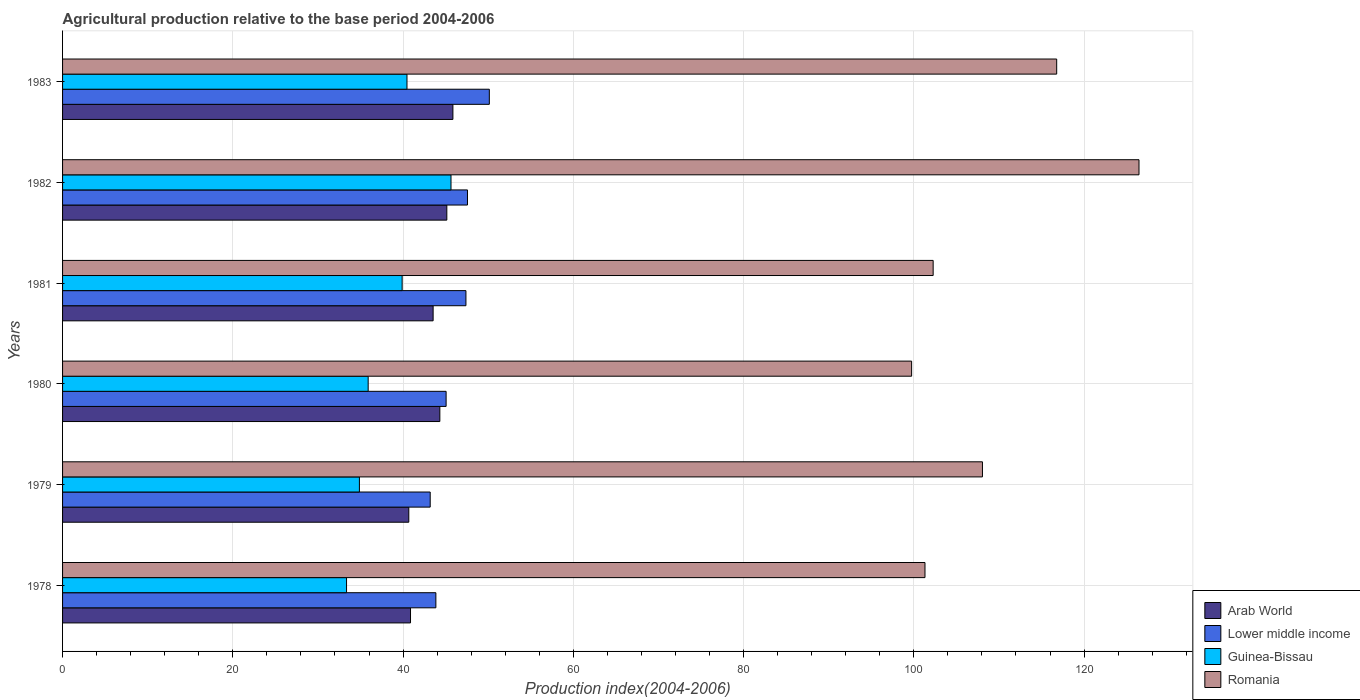Are the number of bars on each tick of the Y-axis equal?
Your response must be concise. Yes. How many bars are there on the 1st tick from the top?
Offer a very short reply. 4. What is the agricultural production index in Romania in 1983?
Give a very brief answer. 116.78. Across all years, what is the maximum agricultural production index in Lower middle income?
Ensure brevity in your answer.  50.13. Across all years, what is the minimum agricultural production index in Guinea-Bissau?
Make the answer very short. 33.36. In which year was the agricultural production index in Romania maximum?
Ensure brevity in your answer.  1982. What is the total agricultural production index in Lower middle income in the graph?
Give a very brief answer. 277.18. What is the difference between the agricultural production index in Arab World in 1980 and that in 1981?
Offer a very short reply. 0.79. What is the difference between the agricultural production index in Arab World in 1981 and the agricultural production index in Guinea-Bissau in 1983?
Provide a short and direct response. 3.07. What is the average agricultural production index in Guinea-Bissau per year?
Your answer should be very brief. 38.35. In the year 1980, what is the difference between the agricultural production index in Arab World and agricultural production index in Guinea-Bissau?
Offer a terse response. 8.42. In how many years, is the agricultural production index in Romania greater than 36 ?
Offer a very short reply. 6. What is the ratio of the agricultural production index in Guinea-Bissau in 1978 to that in 1982?
Your answer should be compact. 0.73. Is the difference between the agricultural production index in Arab World in 1979 and 1980 greater than the difference between the agricultural production index in Guinea-Bissau in 1979 and 1980?
Your response must be concise. No. What is the difference between the highest and the second highest agricultural production index in Arab World?
Make the answer very short. 0.71. What is the difference between the highest and the lowest agricultural production index in Lower middle income?
Your answer should be compact. 6.95. Is the sum of the agricultural production index in Lower middle income in 1982 and 1983 greater than the maximum agricultural production index in Guinea-Bissau across all years?
Provide a succinct answer. Yes. Is it the case that in every year, the sum of the agricultural production index in Romania and agricultural production index in Lower middle income is greater than the sum of agricultural production index in Arab World and agricultural production index in Guinea-Bissau?
Your answer should be compact. Yes. What does the 1st bar from the top in 1978 represents?
Keep it short and to the point. Romania. What does the 3rd bar from the bottom in 1978 represents?
Provide a short and direct response. Guinea-Bissau. How many bars are there?
Your answer should be compact. 24. What is the difference between two consecutive major ticks on the X-axis?
Offer a terse response. 20. Are the values on the major ticks of X-axis written in scientific E-notation?
Your answer should be compact. No. Where does the legend appear in the graph?
Your response must be concise. Bottom right. How are the legend labels stacked?
Your response must be concise. Vertical. What is the title of the graph?
Keep it short and to the point. Agricultural production relative to the base period 2004-2006. Does "Cyprus" appear as one of the legend labels in the graph?
Provide a short and direct response. No. What is the label or title of the X-axis?
Your answer should be compact. Production index(2004-2006). What is the label or title of the Y-axis?
Your response must be concise. Years. What is the Production index(2004-2006) of Arab World in 1978?
Provide a succinct answer. 40.87. What is the Production index(2004-2006) of Lower middle income in 1978?
Ensure brevity in your answer.  43.85. What is the Production index(2004-2006) of Guinea-Bissau in 1978?
Your response must be concise. 33.36. What is the Production index(2004-2006) of Romania in 1978?
Your response must be concise. 101.31. What is the Production index(2004-2006) in Arab World in 1979?
Give a very brief answer. 40.67. What is the Production index(2004-2006) in Lower middle income in 1979?
Your answer should be compact. 43.19. What is the Production index(2004-2006) of Guinea-Bissau in 1979?
Offer a very short reply. 34.87. What is the Production index(2004-2006) of Romania in 1979?
Your answer should be compact. 108.06. What is the Production index(2004-2006) of Arab World in 1980?
Offer a very short reply. 44.32. What is the Production index(2004-2006) of Lower middle income in 1980?
Offer a very short reply. 45.06. What is the Production index(2004-2006) of Guinea-Bissau in 1980?
Your answer should be very brief. 35.9. What is the Production index(2004-2006) of Romania in 1980?
Offer a terse response. 99.74. What is the Production index(2004-2006) in Arab World in 1981?
Ensure brevity in your answer.  43.53. What is the Production index(2004-2006) in Lower middle income in 1981?
Make the answer very short. 47.38. What is the Production index(2004-2006) in Guinea-Bissau in 1981?
Your answer should be compact. 39.89. What is the Production index(2004-2006) in Romania in 1981?
Your answer should be very brief. 102.27. What is the Production index(2004-2006) in Arab World in 1982?
Provide a succinct answer. 45.14. What is the Production index(2004-2006) of Lower middle income in 1982?
Provide a short and direct response. 47.57. What is the Production index(2004-2006) in Guinea-Bissau in 1982?
Offer a very short reply. 45.63. What is the Production index(2004-2006) in Romania in 1982?
Provide a succinct answer. 126.45. What is the Production index(2004-2006) in Arab World in 1983?
Your answer should be very brief. 45.85. What is the Production index(2004-2006) of Lower middle income in 1983?
Your response must be concise. 50.13. What is the Production index(2004-2006) in Guinea-Bissau in 1983?
Your answer should be compact. 40.46. What is the Production index(2004-2006) in Romania in 1983?
Give a very brief answer. 116.78. Across all years, what is the maximum Production index(2004-2006) in Arab World?
Make the answer very short. 45.85. Across all years, what is the maximum Production index(2004-2006) of Lower middle income?
Offer a terse response. 50.13. Across all years, what is the maximum Production index(2004-2006) in Guinea-Bissau?
Provide a succinct answer. 45.63. Across all years, what is the maximum Production index(2004-2006) in Romania?
Give a very brief answer. 126.45. Across all years, what is the minimum Production index(2004-2006) in Arab World?
Make the answer very short. 40.67. Across all years, what is the minimum Production index(2004-2006) in Lower middle income?
Provide a succinct answer. 43.19. Across all years, what is the minimum Production index(2004-2006) of Guinea-Bissau?
Give a very brief answer. 33.36. Across all years, what is the minimum Production index(2004-2006) in Romania?
Ensure brevity in your answer.  99.74. What is the total Production index(2004-2006) of Arab World in the graph?
Your response must be concise. 260.39. What is the total Production index(2004-2006) in Lower middle income in the graph?
Your response must be concise. 277.18. What is the total Production index(2004-2006) of Guinea-Bissau in the graph?
Your answer should be compact. 230.11. What is the total Production index(2004-2006) of Romania in the graph?
Offer a very short reply. 654.61. What is the difference between the Production index(2004-2006) in Arab World in 1978 and that in 1979?
Your response must be concise. 0.2. What is the difference between the Production index(2004-2006) of Lower middle income in 1978 and that in 1979?
Ensure brevity in your answer.  0.67. What is the difference between the Production index(2004-2006) of Guinea-Bissau in 1978 and that in 1979?
Your response must be concise. -1.51. What is the difference between the Production index(2004-2006) of Romania in 1978 and that in 1979?
Give a very brief answer. -6.75. What is the difference between the Production index(2004-2006) in Arab World in 1978 and that in 1980?
Give a very brief answer. -3.45. What is the difference between the Production index(2004-2006) of Lower middle income in 1978 and that in 1980?
Your response must be concise. -1.2. What is the difference between the Production index(2004-2006) in Guinea-Bissau in 1978 and that in 1980?
Make the answer very short. -2.54. What is the difference between the Production index(2004-2006) of Romania in 1978 and that in 1980?
Ensure brevity in your answer.  1.57. What is the difference between the Production index(2004-2006) of Arab World in 1978 and that in 1981?
Offer a terse response. -2.66. What is the difference between the Production index(2004-2006) of Lower middle income in 1978 and that in 1981?
Your answer should be very brief. -3.53. What is the difference between the Production index(2004-2006) of Guinea-Bissau in 1978 and that in 1981?
Keep it short and to the point. -6.53. What is the difference between the Production index(2004-2006) in Romania in 1978 and that in 1981?
Ensure brevity in your answer.  -0.96. What is the difference between the Production index(2004-2006) in Arab World in 1978 and that in 1982?
Your response must be concise. -4.27. What is the difference between the Production index(2004-2006) in Lower middle income in 1978 and that in 1982?
Your response must be concise. -3.71. What is the difference between the Production index(2004-2006) of Guinea-Bissau in 1978 and that in 1982?
Your response must be concise. -12.27. What is the difference between the Production index(2004-2006) in Romania in 1978 and that in 1982?
Provide a succinct answer. -25.14. What is the difference between the Production index(2004-2006) in Arab World in 1978 and that in 1983?
Provide a succinct answer. -4.98. What is the difference between the Production index(2004-2006) of Lower middle income in 1978 and that in 1983?
Your response must be concise. -6.28. What is the difference between the Production index(2004-2006) of Guinea-Bissau in 1978 and that in 1983?
Provide a short and direct response. -7.1. What is the difference between the Production index(2004-2006) in Romania in 1978 and that in 1983?
Provide a short and direct response. -15.47. What is the difference between the Production index(2004-2006) of Arab World in 1979 and that in 1980?
Offer a very short reply. -3.65. What is the difference between the Production index(2004-2006) in Lower middle income in 1979 and that in 1980?
Ensure brevity in your answer.  -1.87. What is the difference between the Production index(2004-2006) in Guinea-Bissau in 1979 and that in 1980?
Offer a very short reply. -1.03. What is the difference between the Production index(2004-2006) in Romania in 1979 and that in 1980?
Your response must be concise. 8.32. What is the difference between the Production index(2004-2006) in Arab World in 1979 and that in 1981?
Provide a short and direct response. -2.86. What is the difference between the Production index(2004-2006) in Lower middle income in 1979 and that in 1981?
Offer a terse response. -4.2. What is the difference between the Production index(2004-2006) in Guinea-Bissau in 1979 and that in 1981?
Keep it short and to the point. -5.02. What is the difference between the Production index(2004-2006) of Romania in 1979 and that in 1981?
Ensure brevity in your answer.  5.79. What is the difference between the Production index(2004-2006) of Arab World in 1979 and that in 1982?
Provide a succinct answer. -4.47. What is the difference between the Production index(2004-2006) of Lower middle income in 1979 and that in 1982?
Ensure brevity in your answer.  -4.38. What is the difference between the Production index(2004-2006) in Guinea-Bissau in 1979 and that in 1982?
Offer a very short reply. -10.76. What is the difference between the Production index(2004-2006) in Romania in 1979 and that in 1982?
Offer a terse response. -18.39. What is the difference between the Production index(2004-2006) of Arab World in 1979 and that in 1983?
Give a very brief answer. -5.18. What is the difference between the Production index(2004-2006) of Lower middle income in 1979 and that in 1983?
Your response must be concise. -6.95. What is the difference between the Production index(2004-2006) of Guinea-Bissau in 1979 and that in 1983?
Ensure brevity in your answer.  -5.59. What is the difference between the Production index(2004-2006) in Romania in 1979 and that in 1983?
Give a very brief answer. -8.72. What is the difference between the Production index(2004-2006) in Arab World in 1980 and that in 1981?
Provide a short and direct response. 0.79. What is the difference between the Production index(2004-2006) in Lower middle income in 1980 and that in 1981?
Offer a terse response. -2.33. What is the difference between the Production index(2004-2006) of Guinea-Bissau in 1980 and that in 1981?
Your answer should be compact. -3.99. What is the difference between the Production index(2004-2006) in Romania in 1980 and that in 1981?
Offer a very short reply. -2.53. What is the difference between the Production index(2004-2006) in Arab World in 1980 and that in 1982?
Provide a succinct answer. -0.82. What is the difference between the Production index(2004-2006) of Lower middle income in 1980 and that in 1982?
Offer a very short reply. -2.51. What is the difference between the Production index(2004-2006) in Guinea-Bissau in 1980 and that in 1982?
Make the answer very short. -9.73. What is the difference between the Production index(2004-2006) of Romania in 1980 and that in 1982?
Give a very brief answer. -26.71. What is the difference between the Production index(2004-2006) in Arab World in 1980 and that in 1983?
Give a very brief answer. -1.54. What is the difference between the Production index(2004-2006) in Lower middle income in 1980 and that in 1983?
Your answer should be very brief. -5.08. What is the difference between the Production index(2004-2006) of Guinea-Bissau in 1980 and that in 1983?
Make the answer very short. -4.56. What is the difference between the Production index(2004-2006) in Romania in 1980 and that in 1983?
Offer a terse response. -17.04. What is the difference between the Production index(2004-2006) in Arab World in 1981 and that in 1982?
Offer a terse response. -1.61. What is the difference between the Production index(2004-2006) of Lower middle income in 1981 and that in 1982?
Give a very brief answer. -0.18. What is the difference between the Production index(2004-2006) in Guinea-Bissau in 1981 and that in 1982?
Offer a very short reply. -5.74. What is the difference between the Production index(2004-2006) in Romania in 1981 and that in 1982?
Offer a very short reply. -24.18. What is the difference between the Production index(2004-2006) of Arab World in 1981 and that in 1983?
Provide a short and direct response. -2.33. What is the difference between the Production index(2004-2006) of Lower middle income in 1981 and that in 1983?
Give a very brief answer. -2.75. What is the difference between the Production index(2004-2006) of Guinea-Bissau in 1981 and that in 1983?
Provide a succinct answer. -0.57. What is the difference between the Production index(2004-2006) of Romania in 1981 and that in 1983?
Give a very brief answer. -14.51. What is the difference between the Production index(2004-2006) of Arab World in 1982 and that in 1983?
Offer a terse response. -0.71. What is the difference between the Production index(2004-2006) in Lower middle income in 1982 and that in 1983?
Give a very brief answer. -2.57. What is the difference between the Production index(2004-2006) in Guinea-Bissau in 1982 and that in 1983?
Provide a short and direct response. 5.17. What is the difference between the Production index(2004-2006) of Romania in 1982 and that in 1983?
Your answer should be compact. 9.67. What is the difference between the Production index(2004-2006) in Arab World in 1978 and the Production index(2004-2006) in Lower middle income in 1979?
Provide a short and direct response. -2.31. What is the difference between the Production index(2004-2006) in Arab World in 1978 and the Production index(2004-2006) in Guinea-Bissau in 1979?
Your answer should be compact. 6. What is the difference between the Production index(2004-2006) of Arab World in 1978 and the Production index(2004-2006) of Romania in 1979?
Make the answer very short. -67.19. What is the difference between the Production index(2004-2006) of Lower middle income in 1978 and the Production index(2004-2006) of Guinea-Bissau in 1979?
Your answer should be compact. 8.98. What is the difference between the Production index(2004-2006) of Lower middle income in 1978 and the Production index(2004-2006) of Romania in 1979?
Make the answer very short. -64.21. What is the difference between the Production index(2004-2006) of Guinea-Bissau in 1978 and the Production index(2004-2006) of Romania in 1979?
Your response must be concise. -74.7. What is the difference between the Production index(2004-2006) in Arab World in 1978 and the Production index(2004-2006) in Lower middle income in 1980?
Keep it short and to the point. -4.18. What is the difference between the Production index(2004-2006) of Arab World in 1978 and the Production index(2004-2006) of Guinea-Bissau in 1980?
Your answer should be very brief. 4.97. What is the difference between the Production index(2004-2006) in Arab World in 1978 and the Production index(2004-2006) in Romania in 1980?
Provide a succinct answer. -58.87. What is the difference between the Production index(2004-2006) in Lower middle income in 1978 and the Production index(2004-2006) in Guinea-Bissau in 1980?
Provide a short and direct response. 7.95. What is the difference between the Production index(2004-2006) of Lower middle income in 1978 and the Production index(2004-2006) of Romania in 1980?
Your response must be concise. -55.89. What is the difference between the Production index(2004-2006) of Guinea-Bissau in 1978 and the Production index(2004-2006) of Romania in 1980?
Make the answer very short. -66.38. What is the difference between the Production index(2004-2006) in Arab World in 1978 and the Production index(2004-2006) in Lower middle income in 1981?
Provide a succinct answer. -6.51. What is the difference between the Production index(2004-2006) of Arab World in 1978 and the Production index(2004-2006) of Guinea-Bissau in 1981?
Provide a short and direct response. 0.98. What is the difference between the Production index(2004-2006) of Arab World in 1978 and the Production index(2004-2006) of Romania in 1981?
Keep it short and to the point. -61.4. What is the difference between the Production index(2004-2006) of Lower middle income in 1978 and the Production index(2004-2006) of Guinea-Bissau in 1981?
Ensure brevity in your answer.  3.96. What is the difference between the Production index(2004-2006) in Lower middle income in 1978 and the Production index(2004-2006) in Romania in 1981?
Offer a terse response. -58.42. What is the difference between the Production index(2004-2006) in Guinea-Bissau in 1978 and the Production index(2004-2006) in Romania in 1981?
Ensure brevity in your answer.  -68.91. What is the difference between the Production index(2004-2006) in Arab World in 1978 and the Production index(2004-2006) in Lower middle income in 1982?
Offer a very short reply. -6.69. What is the difference between the Production index(2004-2006) in Arab World in 1978 and the Production index(2004-2006) in Guinea-Bissau in 1982?
Make the answer very short. -4.76. What is the difference between the Production index(2004-2006) in Arab World in 1978 and the Production index(2004-2006) in Romania in 1982?
Ensure brevity in your answer.  -85.58. What is the difference between the Production index(2004-2006) of Lower middle income in 1978 and the Production index(2004-2006) of Guinea-Bissau in 1982?
Your answer should be compact. -1.78. What is the difference between the Production index(2004-2006) of Lower middle income in 1978 and the Production index(2004-2006) of Romania in 1982?
Your response must be concise. -82.6. What is the difference between the Production index(2004-2006) in Guinea-Bissau in 1978 and the Production index(2004-2006) in Romania in 1982?
Keep it short and to the point. -93.09. What is the difference between the Production index(2004-2006) in Arab World in 1978 and the Production index(2004-2006) in Lower middle income in 1983?
Offer a very short reply. -9.26. What is the difference between the Production index(2004-2006) of Arab World in 1978 and the Production index(2004-2006) of Guinea-Bissau in 1983?
Provide a short and direct response. 0.41. What is the difference between the Production index(2004-2006) in Arab World in 1978 and the Production index(2004-2006) in Romania in 1983?
Offer a terse response. -75.91. What is the difference between the Production index(2004-2006) in Lower middle income in 1978 and the Production index(2004-2006) in Guinea-Bissau in 1983?
Your answer should be compact. 3.39. What is the difference between the Production index(2004-2006) in Lower middle income in 1978 and the Production index(2004-2006) in Romania in 1983?
Your response must be concise. -72.93. What is the difference between the Production index(2004-2006) in Guinea-Bissau in 1978 and the Production index(2004-2006) in Romania in 1983?
Ensure brevity in your answer.  -83.42. What is the difference between the Production index(2004-2006) in Arab World in 1979 and the Production index(2004-2006) in Lower middle income in 1980?
Ensure brevity in your answer.  -4.38. What is the difference between the Production index(2004-2006) in Arab World in 1979 and the Production index(2004-2006) in Guinea-Bissau in 1980?
Offer a very short reply. 4.77. What is the difference between the Production index(2004-2006) in Arab World in 1979 and the Production index(2004-2006) in Romania in 1980?
Ensure brevity in your answer.  -59.07. What is the difference between the Production index(2004-2006) in Lower middle income in 1979 and the Production index(2004-2006) in Guinea-Bissau in 1980?
Offer a terse response. 7.29. What is the difference between the Production index(2004-2006) of Lower middle income in 1979 and the Production index(2004-2006) of Romania in 1980?
Your answer should be compact. -56.55. What is the difference between the Production index(2004-2006) of Guinea-Bissau in 1979 and the Production index(2004-2006) of Romania in 1980?
Provide a succinct answer. -64.87. What is the difference between the Production index(2004-2006) in Arab World in 1979 and the Production index(2004-2006) in Lower middle income in 1981?
Ensure brevity in your answer.  -6.71. What is the difference between the Production index(2004-2006) of Arab World in 1979 and the Production index(2004-2006) of Guinea-Bissau in 1981?
Offer a very short reply. 0.78. What is the difference between the Production index(2004-2006) of Arab World in 1979 and the Production index(2004-2006) of Romania in 1981?
Your answer should be compact. -61.6. What is the difference between the Production index(2004-2006) in Lower middle income in 1979 and the Production index(2004-2006) in Guinea-Bissau in 1981?
Your answer should be very brief. 3.3. What is the difference between the Production index(2004-2006) in Lower middle income in 1979 and the Production index(2004-2006) in Romania in 1981?
Ensure brevity in your answer.  -59.08. What is the difference between the Production index(2004-2006) of Guinea-Bissau in 1979 and the Production index(2004-2006) of Romania in 1981?
Provide a succinct answer. -67.4. What is the difference between the Production index(2004-2006) in Arab World in 1979 and the Production index(2004-2006) in Lower middle income in 1982?
Provide a succinct answer. -6.89. What is the difference between the Production index(2004-2006) of Arab World in 1979 and the Production index(2004-2006) of Guinea-Bissau in 1982?
Offer a very short reply. -4.96. What is the difference between the Production index(2004-2006) of Arab World in 1979 and the Production index(2004-2006) of Romania in 1982?
Your response must be concise. -85.78. What is the difference between the Production index(2004-2006) in Lower middle income in 1979 and the Production index(2004-2006) in Guinea-Bissau in 1982?
Your answer should be very brief. -2.44. What is the difference between the Production index(2004-2006) in Lower middle income in 1979 and the Production index(2004-2006) in Romania in 1982?
Offer a very short reply. -83.26. What is the difference between the Production index(2004-2006) in Guinea-Bissau in 1979 and the Production index(2004-2006) in Romania in 1982?
Your response must be concise. -91.58. What is the difference between the Production index(2004-2006) in Arab World in 1979 and the Production index(2004-2006) in Lower middle income in 1983?
Offer a very short reply. -9.46. What is the difference between the Production index(2004-2006) of Arab World in 1979 and the Production index(2004-2006) of Guinea-Bissau in 1983?
Make the answer very short. 0.21. What is the difference between the Production index(2004-2006) of Arab World in 1979 and the Production index(2004-2006) of Romania in 1983?
Keep it short and to the point. -76.11. What is the difference between the Production index(2004-2006) of Lower middle income in 1979 and the Production index(2004-2006) of Guinea-Bissau in 1983?
Provide a short and direct response. 2.73. What is the difference between the Production index(2004-2006) in Lower middle income in 1979 and the Production index(2004-2006) in Romania in 1983?
Make the answer very short. -73.59. What is the difference between the Production index(2004-2006) in Guinea-Bissau in 1979 and the Production index(2004-2006) in Romania in 1983?
Keep it short and to the point. -81.91. What is the difference between the Production index(2004-2006) of Arab World in 1980 and the Production index(2004-2006) of Lower middle income in 1981?
Provide a succinct answer. -3.07. What is the difference between the Production index(2004-2006) of Arab World in 1980 and the Production index(2004-2006) of Guinea-Bissau in 1981?
Keep it short and to the point. 4.43. What is the difference between the Production index(2004-2006) of Arab World in 1980 and the Production index(2004-2006) of Romania in 1981?
Make the answer very short. -57.95. What is the difference between the Production index(2004-2006) of Lower middle income in 1980 and the Production index(2004-2006) of Guinea-Bissau in 1981?
Keep it short and to the point. 5.17. What is the difference between the Production index(2004-2006) in Lower middle income in 1980 and the Production index(2004-2006) in Romania in 1981?
Give a very brief answer. -57.21. What is the difference between the Production index(2004-2006) in Guinea-Bissau in 1980 and the Production index(2004-2006) in Romania in 1981?
Ensure brevity in your answer.  -66.37. What is the difference between the Production index(2004-2006) in Arab World in 1980 and the Production index(2004-2006) in Lower middle income in 1982?
Offer a very short reply. -3.25. What is the difference between the Production index(2004-2006) of Arab World in 1980 and the Production index(2004-2006) of Guinea-Bissau in 1982?
Keep it short and to the point. -1.31. What is the difference between the Production index(2004-2006) in Arab World in 1980 and the Production index(2004-2006) in Romania in 1982?
Keep it short and to the point. -82.13. What is the difference between the Production index(2004-2006) of Lower middle income in 1980 and the Production index(2004-2006) of Guinea-Bissau in 1982?
Your response must be concise. -0.57. What is the difference between the Production index(2004-2006) in Lower middle income in 1980 and the Production index(2004-2006) in Romania in 1982?
Your answer should be compact. -81.39. What is the difference between the Production index(2004-2006) in Guinea-Bissau in 1980 and the Production index(2004-2006) in Romania in 1982?
Ensure brevity in your answer.  -90.55. What is the difference between the Production index(2004-2006) in Arab World in 1980 and the Production index(2004-2006) in Lower middle income in 1983?
Give a very brief answer. -5.81. What is the difference between the Production index(2004-2006) of Arab World in 1980 and the Production index(2004-2006) of Guinea-Bissau in 1983?
Offer a terse response. 3.86. What is the difference between the Production index(2004-2006) of Arab World in 1980 and the Production index(2004-2006) of Romania in 1983?
Keep it short and to the point. -72.46. What is the difference between the Production index(2004-2006) in Lower middle income in 1980 and the Production index(2004-2006) in Guinea-Bissau in 1983?
Provide a short and direct response. 4.6. What is the difference between the Production index(2004-2006) of Lower middle income in 1980 and the Production index(2004-2006) of Romania in 1983?
Your answer should be very brief. -71.72. What is the difference between the Production index(2004-2006) of Guinea-Bissau in 1980 and the Production index(2004-2006) of Romania in 1983?
Make the answer very short. -80.88. What is the difference between the Production index(2004-2006) in Arab World in 1981 and the Production index(2004-2006) in Lower middle income in 1982?
Your response must be concise. -4.04. What is the difference between the Production index(2004-2006) in Arab World in 1981 and the Production index(2004-2006) in Guinea-Bissau in 1982?
Give a very brief answer. -2.1. What is the difference between the Production index(2004-2006) in Arab World in 1981 and the Production index(2004-2006) in Romania in 1982?
Your answer should be compact. -82.92. What is the difference between the Production index(2004-2006) in Lower middle income in 1981 and the Production index(2004-2006) in Guinea-Bissau in 1982?
Provide a short and direct response. 1.75. What is the difference between the Production index(2004-2006) of Lower middle income in 1981 and the Production index(2004-2006) of Romania in 1982?
Provide a short and direct response. -79.07. What is the difference between the Production index(2004-2006) in Guinea-Bissau in 1981 and the Production index(2004-2006) in Romania in 1982?
Ensure brevity in your answer.  -86.56. What is the difference between the Production index(2004-2006) of Arab World in 1981 and the Production index(2004-2006) of Lower middle income in 1983?
Your response must be concise. -6.6. What is the difference between the Production index(2004-2006) of Arab World in 1981 and the Production index(2004-2006) of Guinea-Bissau in 1983?
Your answer should be compact. 3.07. What is the difference between the Production index(2004-2006) in Arab World in 1981 and the Production index(2004-2006) in Romania in 1983?
Make the answer very short. -73.25. What is the difference between the Production index(2004-2006) of Lower middle income in 1981 and the Production index(2004-2006) of Guinea-Bissau in 1983?
Your response must be concise. 6.92. What is the difference between the Production index(2004-2006) in Lower middle income in 1981 and the Production index(2004-2006) in Romania in 1983?
Ensure brevity in your answer.  -69.4. What is the difference between the Production index(2004-2006) in Guinea-Bissau in 1981 and the Production index(2004-2006) in Romania in 1983?
Keep it short and to the point. -76.89. What is the difference between the Production index(2004-2006) in Arab World in 1982 and the Production index(2004-2006) in Lower middle income in 1983?
Your response must be concise. -4.99. What is the difference between the Production index(2004-2006) in Arab World in 1982 and the Production index(2004-2006) in Guinea-Bissau in 1983?
Your response must be concise. 4.68. What is the difference between the Production index(2004-2006) in Arab World in 1982 and the Production index(2004-2006) in Romania in 1983?
Make the answer very short. -71.64. What is the difference between the Production index(2004-2006) of Lower middle income in 1982 and the Production index(2004-2006) of Guinea-Bissau in 1983?
Provide a short and direct response. 7.11. What is the difference between the Production index(2004-2006) in Lower middle income in 1982 and the Production index(2004-2006) in Romania in 1983?
Offer a very short reply. -69.21. What is the difference between the Production index(2004-2006) of Guinea-Bissau in 1982 and the Production index(2004-2006) of Romania in 1983?
Your answer should be compact. -71.15. What is the average Production index(2004-2006) in Arab World per year?
Ensure brevity in your answer.  43.4. What is the average Production index(2004-2006) of Lower middle income per year?
Ensure brevity in your answer.  46.2. What is the average Production index(2004-2006) of Guinea-Bissau per year?
Your response must be concise. 38.35. What is the average Production index(2004-2006) in Romania per year?
Your response must be concise. 109.1. In the year 1978, what is the difference between the Production index(2004-2006) in Arab World and Production index(2004-2006) in Lower middle income?
Make the answer very short. -2.98. In the year 1978, what is the difference between the Production index(2004-2006) of Arab World and Production index(2004-2006) of Guinea-Bissau?
Your answer should be very brief. 7.51. In the year 1978, what is the difference between the Production index(2004-2006) of Arab World and Production index(2004-2006) of Romania?
Make the answer very short. -60.44. In the year 1978, what is the difference between the Production index(2004-2006) of Lower middle income and Production index(2004-2006) of Guinea-Bissau?
Give a very brief answer. 10.49. In the year 1978, what is the difference between the Production index(2004-2006) in Lower middle income and Production index(2004-2006) in Romania?
Make the answer very short. -57.46. In the year 1978, what is the difference between the Production index(2004-2006) in Guinea-Bissau and Production index(2004-2006) in Romania?
Offer a very short reply. -67.95. In the year 1979, what is the difference between the Production index(2004-2006) in Arab World and Production index(2004-2006) in Lower middle income?
Your response must be concise. -2.51. In the year 1979, what is the difference between the Production index(2004-2006) in Arab World and Production index(2004-2006) in Guinea-Bissau?
Offer a very short reply. 5.8. In the year 1979, what is the difference between the Production index(2004-2006) of Arab World and Production index(2004-2006) of Romania?
Your answer should be very brief. -67.39. In the year 1979, what is the difference between the Production index(2004-2006) in Lower middle income and Production index(2004-2006) in Guinea-Bissau?
Provide a succinct answer. 8.32. In the year 1979, what is the difference between the Production index(2004-2006) of Lower middle income and Production index(2004-2006) of Romania?
Your answer should be compact. -64.87. In the year 1979, what is the difference between the Production index(2004-2006) of Guinea-Bissau and Production index(2004-2006) of Romania?
Give a very brief answer. -73.19. In the year 1980, what is the difference between the Production index(2004-2006) of Arab World and Production index(2004-2006) of Lower middle income?
Your answer should be compact. -0.74. In the year 1980, what is the difference between the Production index(2004-2006) in Arab World and Production index(2004-2006) in Guinea-Bissau?
Provide a short and direct response. 8.42. In the year 1980, what is the difference between the Production index(2004-2006) in Arab World and Production index(2004-2006) in Romania?
Your response must be concise. -55.42. In the year 1980, what is the difference between the Production index(2004-2006) in Lower middle income and Production index(2004-2006) in Guinea-Bissau?
Your answer should be very brief. 9.16. In the year 1980, what is the difference between the Production index(2004-2006) in Lower middle income and Production index(2004-2006) in Romania?
Your response must be concise. -54.68. In the year 1980, what is the difference between the Production index(2004-2006) in Guinea-Bissau and Production index(2004-2006) in Romania?
Your answer should be very brief. -63.84. In the year 1981, what is the difference between the Production index(2004-2006) of Arab World and Production index(2004-2006) of Lower middle income?
Provide a short and direct response. -3.86. In the year 1981, what is the difference between the Production index(2004-2006) of Arab World and Production index(2004-2006) of Guinea-Bissau?
Your answer should be compact. 3.64. In the year 1981, what is the difference between the Production index(2004-2006) in Arab World and Production index(2004-2006) in Romania?
Provide a short and direct response. -58.74. In the year 1981, what is the difference between the Production index(2004-2006) in Lower middle income and Production index(2004-2006) in Guinea-Bissau?
Provide a succinct answer. 7.49. In the year 1981, what is the difference between the Production index(2004-2006) of Lower middle income and Production index(2004-2006) of Romania?
Make the answer very short. -54.89. In the year 1981, what is the difference between the Production index(2004-2006) of Guinea-Bissau and Production index(2004-2006) of Romania?
Keep it short and to the point. -62.38. In the year 1982, what is the difference between the Production index(2004-2006) of Arab World and Production index(2004-2006) of Lower middle income?
Your answer should be very brief. -2.43. In the year 1982, what is the difference between the Production index(2004-2006) in Arab World and Production index(2004-2006) in Guinea-Bissau?
Provide a succinct answer. -0.49. In the year 1982, what is the difference between the Production index(2004-2006) in Arab World and Production index(2004-2006) in Romania?
Your answer should be very brief. -81.31. In the year 1982, what is the difference between the Production index(2004-2006) in Lower middle income and Production index(2004-2006) in Guinea-Bissau?
Keep it short and to the point. 1.94. In the year 1982, what is the difference between the Production index(2004-2006) in Lower middle income and Production index(2004-2006) in Romania?
Give a very brief answer. -78.88. In the year 1982, what is the difference between the Production index(2004-2006) of Guinea-Bissau and Production index(2004-2006) of Romania?
Offer a very short reply. -80.82. In the year 1983, what is the difference between the Production index(2004-2006) of Arab World and Production index(2004-2006) of Lower middle income?
Offer a terse response. -4.28. In the year 1983, what is the difference between the Production index(2004-2006) in Arab World and Production index(2004-2006) in Guinea-Bissau?
Ensure brevity in your answer.  5.39. In the year 1983, what is the difference between the Production index(2004-2006) of Arab World and Production index(2004-2006) of Romania?
Your response must be concise. -70.93. In the year 1983, what is the difference between the Production index(2004-2006) of Lower middle income and Production index(2004-2006) of Guinea-Bissau?
Your answer should be very brief. 9.67. In the year 1983, what is the difference between the Production index(2004-2006) of Lower middle income and Production index(2004-2006) of Romania?
Give a very brief answer. -66.65. In the year 1983, what is the difference between the Production index(2004-2006) in Guinea-Bissau and Production index(2004-2006) in Romania?
Your answer should be very brief. -76.32. What is the ratio of the Production index(2004-2006) of Lower middle income in 1978 to that in 1979?
Keep it short and to the point. 1.02. What is the ratio of the Production index(2004-2006) of Guinea-Bissau in 1978 to that in 1979?
Ensure brevity in your answer.  0.96. What is the ratio of the Production index(2004-2006) in Arab World in 1978 to that in 1980?
Ensure brevity in your answer.  0.92. What is the ratio of the Production index(2004-2006) in Lower middle income in 1978 to that in 1980?
Keep it short and to the point. 0.97. What is the ratio of the Production index(2004-2006) in Guinea-Bissau in 1978 to that in 1980?
Give a very brief answer. 0.93. What is the ratio of the Production index(2004-2006) in Romania in 1978 to that in 1980?
Offer a very short reply. 1.02. What is the ratio of the Production index(2004-2006) of Arab World in 1978 to that in 1981?
Your answer should be very brief. 0.94. What is the ratio of the Production index(2004-2006) of Lower middle income in 1978 to that in 1981?
Make the answer very short. 0.93. What is the ratio of the Production index(2004-2006) in Guinea-Bissau in 1978 to that in 1981?
Give a very brief answer. 0.84. What is the ratio of the Production index(2004-2006) of Romania in 1978 to that in 1981?
Your answer should be compact. 0.99. What is the ratio of the Production index(2004-2006) of Arab World in 1978 to that in 1982?
Your response must be concise. 0.91. What is the ratio of the Production index(2004-2006) in Lower middle income in 1978 to that in 1982?
Ensure brevity in your answer.  0.92. What is the ratio of the Production index(2004-2006) of Guinea-Bissau in 1978 to that in 1982?
Offer a very short reply. 0.73. What is the ratio of the Production index(2004-2006) in Romania in 1978 to that in 1982?
Offer a terse response. 0.8. What is the ratio of the Production index(2004-2006) of Arab World in 1978 to that in 1983?
Give a very brief answer. 0.89. What is the ratio of the Production index(2004-2006) in Lower middle income in 1978 to that in 1983?
Give a very brief answer. 0.87. What is the ratio of the Production index(2004-2006) in Guinea-Bissau in 1978 to that in 1983?
Your answer should be compact. 0.82. What is the ratio of the Production index(2004-2006) in Romania in 1978 to that in 1983?
Offer a very short reply. 0.87. What is the ratio of the Production index(2004-2006) of Arab World in 1979 to that in 1980?
Give a very brief answer. 0.92. What is the ratio of the Production index(2004-2006) of Lower middle income in 1979 to that in 1980?
Provide a succinct answer. 0.96. What is the ratio of the Production index(2004-2006) in Guinea-Bissau in 1979 to that in 1980?
Your answer should be very brief. 0.97. What is the ratio of the Production index(2004-2006) in Romania in 1979 to that in 1980?
Your response must be concise. 1.08. What is the ratio of the Production index(2004-2006) of Arab World in 1979 to that in 1981?
Your answer should be compact. 0.93. What is the ratio of the Production index(2004-2006) of Lower middle income in 1979 to that in 1981?
Offer a very short reply. 0.91. What is the ratio of the Production index(2004-2006) in Guinea-Bissau in 1979 to that in 1981?
Give a very brief answer. 0.87. What is the ratio of the Production index(2004-2006) in Romania in 1979 to that in 1981?
Your answer should be compact. 1.06. What is the ratio of the Production index(2004-2006) of Arab World in 1979 to that in 1982?
Ensure brevity in your answer.  0.9. What is the ratio of the Production index(2004-2006) of Lower middle income in 1979 to that in 1982?
Provide a succinct answer. 0.91. What is the ratio of the Production index(2004-2006) in Guinea-Bissau in 1979 to that in 1982?
Ensure brevity in your answer.  0.76. What is the ratio of the Production index(2004-2006) of Romania in 1979 to that in 1982?
Provide a short and direct response. 0.85. What is the ratio of the Production index(2004-2006) in Arab World in 1979 to that in 1983?
Your answer should be compact. 0.89. What is the ratio of the Production index(2004-2006) in Lower middle income in 1979 to that in 1983?
Your answer should be very brief. 0.86. What is the ratio of the Production index(2004-2006) of Guinea-Bissau in 1979 to that in 1983?
Provide a succinct answer. 0.86. What is the ratio of the Production index(2004-2006) in Romania in 1979 to that in 1983?
Give a very brief answer. 0.93. What is the ratio of the Production index(2004-2006) in Arab World in 1980 to that in 1981?
Your answer should be compact. 1.02. What is the ratio of the Production index(2004-2006) in Lower middle income in 1980 to that in 1981?
Make the answer very short. 0.95. What is the ratio of the Production index(2004-2006) in Romania in 1980 to that in 1981?
Offer a very short reply. 0.98. What is the ratio of the Production index(2004-2006) of Arab World in 1980 to that in 1982?
Provide a short and direct response. 0.98. What is the ratio of the Production index(2004-2006) of Lower middle income in 1980 to that in 1982?
Provide a short and direct response. 0.95. What is the ratio of the Production index(2004-2006) of Guinea-Bissau in 1980 to that in 1982?
Make the answer very short. 0.79. What is the ratio of the Production index(2004-2006) of Romania in 1980 to that in 1982?
Your answer should be compact. 0.79. What is the ratio of the Production index(2004-2006) in Arab World in 1980 to that in 1983?
Make the answer very short. 0.97. What is the ratio of the Production index(2004-2006) of Lower middle income in 1980 to that in 1983?
Make the answer very short. 0.9. What is the ratio of the Production index(2004-2006) of Guinea-Bissau in 1980 to that in 1983?
Your answer should be very brief. 0.89. What is the ratio of the Production index(2004-2006) of Romania in 1980 to that in 1983?
Provide a succinct answer. 0.85. What is the ratio of the Production index(2004-2006) of Arab World in 1981 to that in 1982?
Offer a very short reply. 0.96. What is the ratio of the Production index(2004-2006) in Guinea-Bissau in 1981 to that in 1982?
Provide a short and direct response. 0.87. What is the ratio of the Production index(2004-2006) in Romania in 1981 to that in 1982?
Your answer should be compact. 0.81. What is the ratio of the Production index(2004-2006) in Arab World in 1981 to that in 1983?
Ensure brevity in your answer.  0.95. What is the ratio of the Production index(2004-2006) in Lower middle income in 1981 to that in 1983?
Provide a succinct answer. 0.95. What is the ratio of the Production index(2004-2006) of Guinea-Bissau in 1981 to that in 1983?
Provide a succinct answer. 0.99. What is the ratio of the Production index(2004-2006) of Romania in 1981 to that in 1983?
Your response must be concise. 0.88. What is the ratio of the Production index(2004-2006) in Arab World in 1982 to that in 1983?
Offer a terse response. 0.98. What is the ratio of the Production index(2004-2006) in Lower middle income in 1982 to that in 1983?
Provide a short and direct response. 0.95. What is the ratio of the Production index(2004-2006) of Guinea-Bissau in 1982 to that in 1983?
Your answer should be very brief. 1.13. What is the ratio of the Production index(2004-2006) of Romania in 1982 to that in 1983?
Make the answer very short. 1.08. What is the difference between the highest and the second highest Production index(2004-2006) in Arab World?
Your answer should be compact. 0.71. What is the difference between the highest and the second highest Production index(2004-2006) in Lower middle income?
Your answer should be very brief. 2.57. What is the difference between the highest and the second highest Production index(2004-2006) in Guinea-Bissau?
Your answer should be very brief. 5.17. What is the difference between the highest and the second highest Production index(2004-2006) in Romania?
Keep it short and to the point. 9.67. What is the difference between the highest and the lowest Production index(2004-2006) in Arab World?
Give a very brief answer. 5.18. What is the difference between the highest and the lowest Production index(2004-2006) of Lower middle income?
Keep it short and to the point. 6.95. What is the difference between the highest and the lowest Production index(2004-2006) of Guinea-Bissau?
Provide a short and direct response. 12.27. What is the difference between the highest and the lowest Production index(2004-2006) of Romania?
Your answer should be compact. 26.71. 